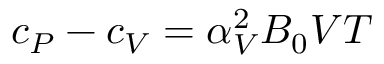Convert formula to latex. <formula><loc_0><loc_0><loc_500><loc_500>c _ { P } - c _ { V } = \alpha _ { V } ^ { 2 } B _ { 0 } V T</formula> 